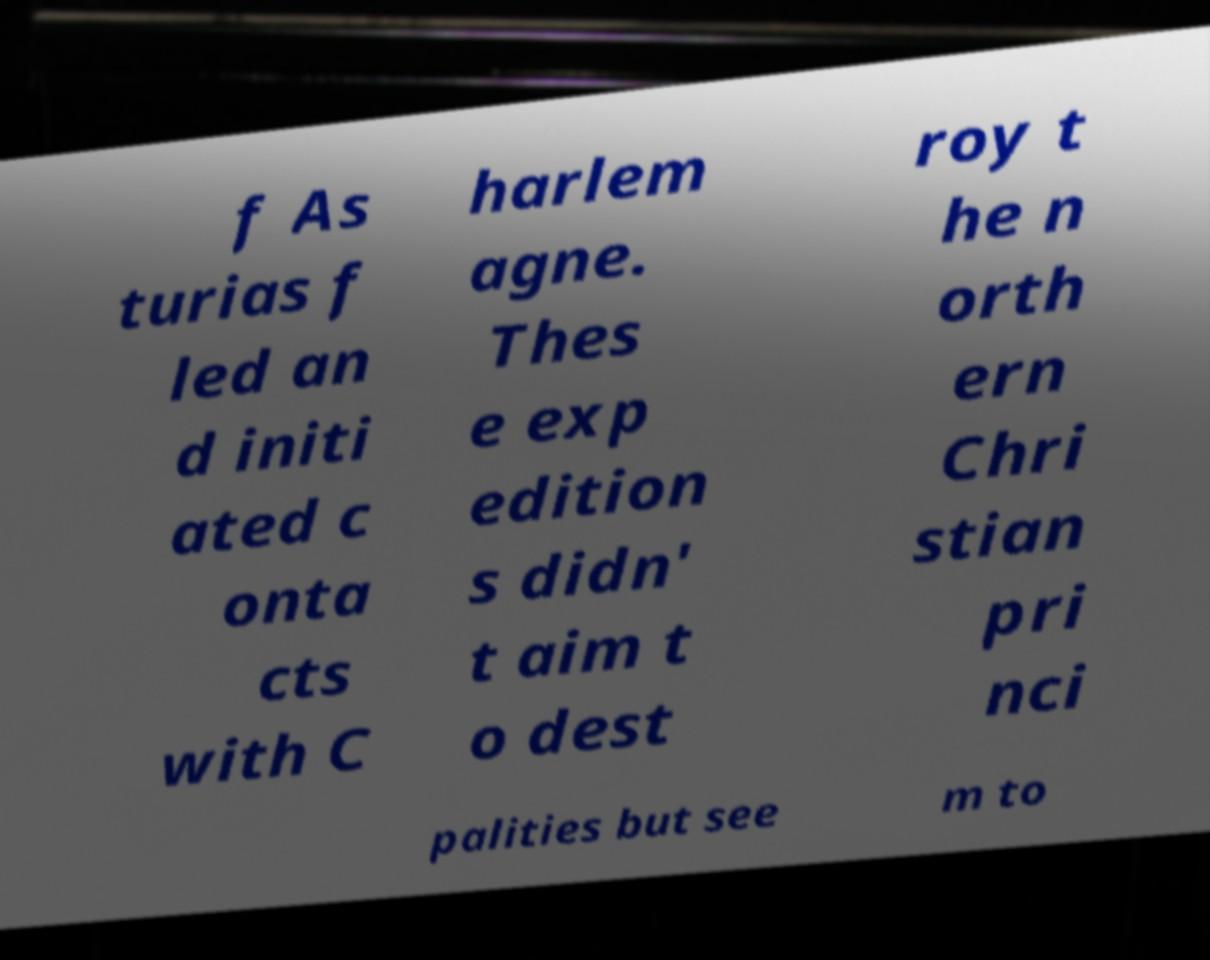Could you extract and type out the text from this image? f As turias f led an d initi ated c onta cts with C harlem agne. Thes e exp edition s didn' t aim t o dest roy t he n orth ern Chri stian pri nci palities but see m to 